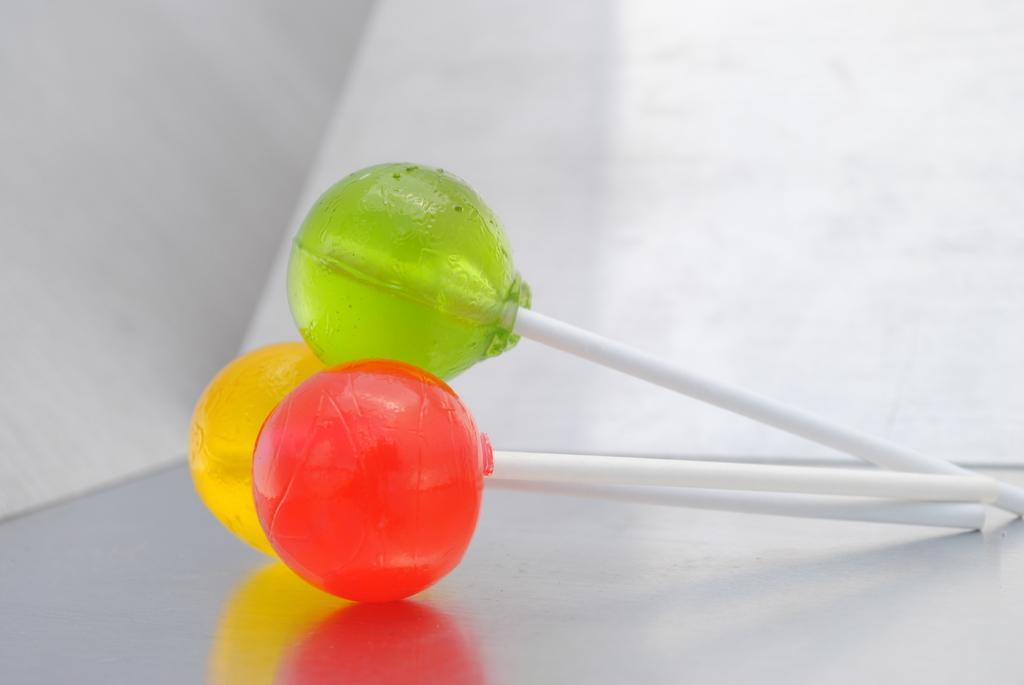Please provide a concise description of this image. In this image we can see yellow, red and green color lollipops are placed on the surface. The background of the image is in white color. 